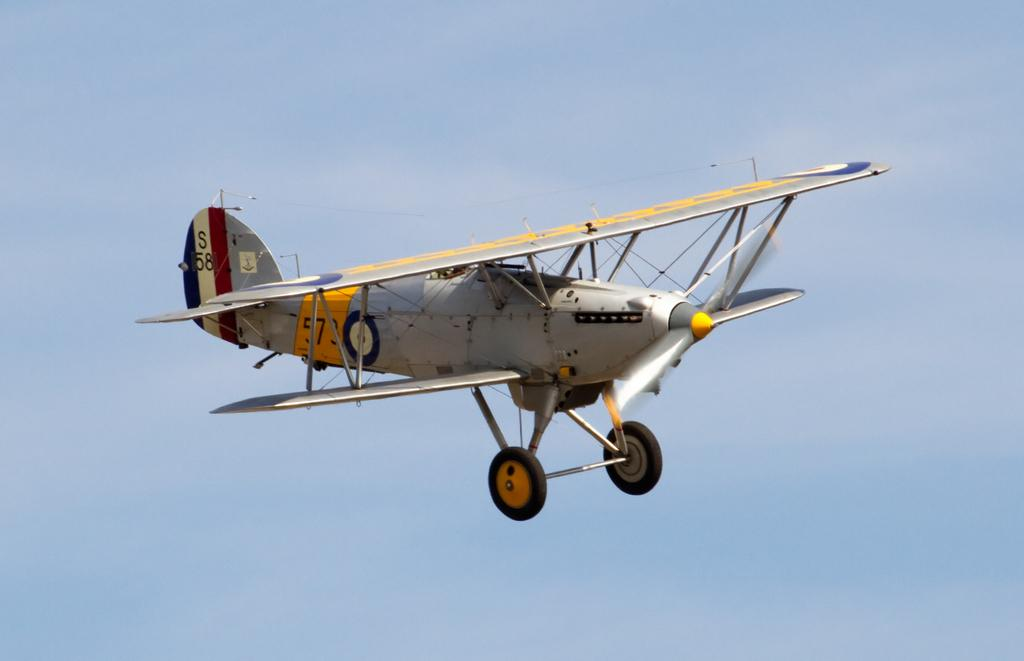What is the main subject of the image? The main subject of the image is an aircraft. Can you describe the position of the aircraft in the image? The aircraft is in the air in the image. What can be seen in the background of the image? The background of the image is covered by the sky. When was the image taken? The image was taken during the day. How many men are holding the bat in the image? There are no men or bats present in the image; it features an aircraft in the sky. 